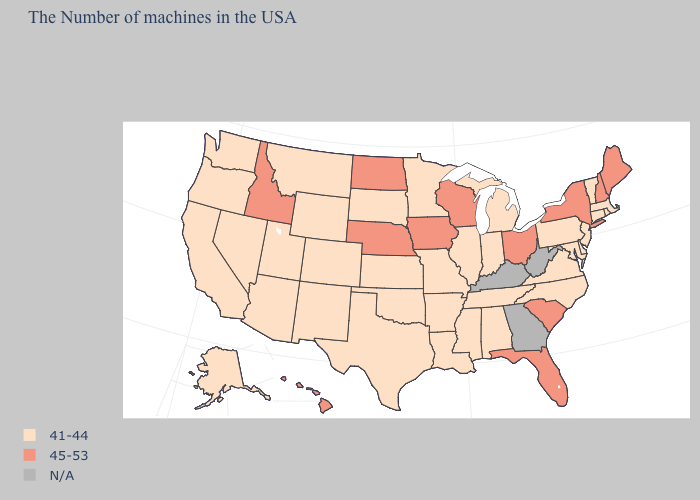Name the states that have a value in the range 45-53?
Give a very brief answer. Maine, New Hampshire, New York, South Carolina, Ohio, Florida, Wisconsin, Iowa, Nebraska, North Dakota, Idaho, Hawaii. Does the map have missing data?
Write a very short answer. Yes. Among the states that border North Carolina , which have the highest value?
Be succinct. South Carolina. What is the highest value in the USA?
Be succinct. 45-53. What is the value of Hawaii?
Answer briefly. 45-53. Among the states that border Connecticut , which have the highest value?
Concise answer only. New York. Does the map have missing data?
Write a very short answer. Yes. What is the value of Utah?
Concise answer only. 41-44. Does the map have missing data?
Keep it brief. Yes. Name the states that have a value in the range 45-53?
Concise answer only. Maine, New Hampshire, New York, South Carolina, Ohio, Florida, Wisconsin, Iowa, Nebraska, North Dakota, Idaho, Hawaii. What is the value of South Carolina?
Answer briefly. 45-53. Does Colorado have the lowest value in the USA?
Keep it brief. Yes. What is the value of North Dakota?
Keep it brief. 45-53. Name the states that have a value in the range 41-44?
Short answer required. Massachusetts, Rhode Island, Vermont, Connecticut, New Jersey, Delaware, Maryland, Pennsylvania, Virginia, North Carolina, Michigan, Indiana, Alabama, Tennessee, Illinois, Mississippi, Louisiana, Missouri, Arkansas, Minnesota, Kansas, Oklahoma, Texas, South Dakota, Wyoming, Colorado, New Mexico, Utah, Montana, Arizona, Nevada, California, Washington, Oregon, Alaska. Which states have the lowest value in the USA?
Quick response, please. Massachusetts, Rhode Island, Vermont, Connecticut, New Jersey, Delaware, Maryland, Pennsylvania, Virginia, North Carolina, Michigan, Indiana, Alabama, Tennessee, Illinois, Mississippi, Louisiana, Missouri, Arkansas, Minnesota, Kansas, Oklahoma, Texas, South Dakota, Wyoming, Colorado, New Mexico, Utah, Montana, Arizona, Nevada, California, Washington, Oregon, Alaska. 